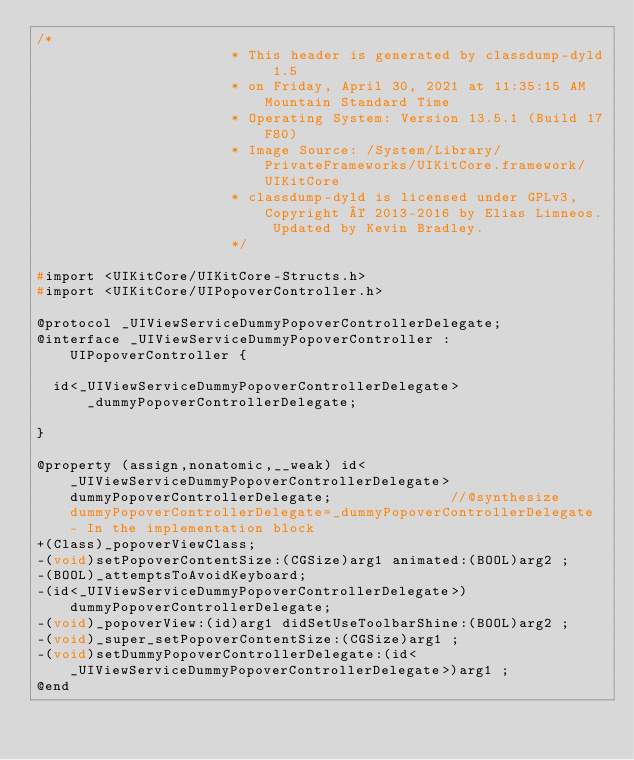<code> <loc_0><loc_0><loc_500><loc_500><_C_>/*
                       * This header is generated by classdump-dyld 1.5
                       * on Friday, April 30, 2021 at 11:35:15 AM Mountain Standard Time
                       * Operating System: Version 13.5.1 (Build 17F80)
                       * Image Source: /System/Library/PrivateFrameworks/UIKitCore.framework/UIKitCore
                       * classdump-dyld is licensed under GPLv3, Copyright © 2013-2016 by Elias Limneos. Updated by Kevin Bradley.
                       */

#import <UIKitCore/UIKitCore-Structs.h>
#import <UIKitCore/UIPopoverController.h>

@protocol _UIViewServiceDummyPopoverControllerDelegate;
@interface _UIViewServiceDummyPopoverController : UIPopoverController {

	id<_UIViewServiceDummyPopoverControllerDelegate> _dummyPopoverControllerDelegate;

}

@property (assign,nonatomic,__weak) id<_UIViewServiceDummyPopoverControllerDelegate> dummyPopoverControllerDelegate;              //@synthesize dummyPopoverControllerDelegate=_dummyPopoverControllerDelegate - In the implementation block
+(Class)_popoverViewClass;
-(void)setPopoverContentSize:(CGSize)arg1 animated:(BOOL)arg2 ;
-(BOOL)_attemptsToAvoidKeyboard;
-(id<_UIViewServiceDummyPopoverControllerDelegate>)dummyPopoverControllerDelegate;
-(void)_popoverView:(id)arg1 didSetUseToolbarShine:(BOOL)arg2 ;
-(void)_super_setPopoverContentSize:(CGSize)arg1 ;
-(void)setDummyPopoverControllerDelegate:(id<_UIViewServiceDummyPopoverControllerDelegate>)arg1 ;
@end

</code> 